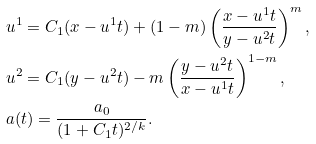Convert formula to latex. <formula><loc_0><loc_0><loc_500><loc_500>& u ^ { 1 } = C _ { 1 } ( x - u ^ { 1 } t ) + ( 1 - m ) \left ( \frac { x - u ^ { 1 } t } { y - u ^ { 2 } t } \right ) ^ { m } , \\ & u ^ { 2 } = C _ { 1 } ( y - u ^ { 2 } t ) - m \left ( \frac { y - u ^ { 2 } t } { x - u ^ { 1 } t } \right ) ^ { 1 - m } , \\ & a ( t ) = \frac { a _ { 0 } } { ( 1 + C _ { 1 } t ) ^ { 2 / k } } .</formula> 